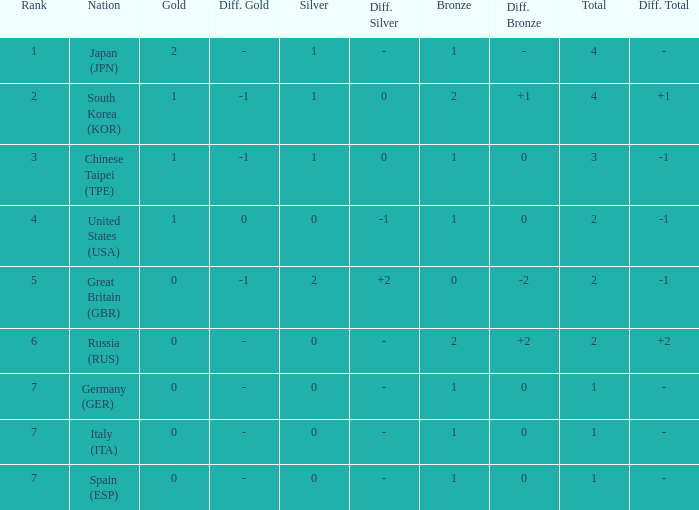What is the smallest number of gold of a country of rank 6, with 2 bronzes? None. Parse the full table. {'header': ['Rank', 'Nation', 'Gold', 'Diff. Gold', 'Silver', 'Diff. Silver', 'Bronze', 'Diff. Bronze', 'Total', 'Diff. Total'], 'rows': [['1', 'Japan (JPN)', '2', '-', '1', '-', '1', '-', '4', '-'], ['2', 'South Korea (KOR)', '1', '-1', '1', '0', '2', '+1', '4', '+1'], ['3', 'Chinese Taipei (TPE)', '1', '-1', '1', '0', '1', '0', '3', '-1'], ['4', 'United States (USA)', '1', '0', '0', '-1', '1', '0', '2', '-1'], ['5', 'Great Britain (GBR)', '0', '-1', '2', '+2', '0', '-2', '2', '-1'], ['6', 'Russia (RUS)', '0', '-', '0', '-', '2', '+2', '2', '+2'], ['7', 'Germany (GER)', '0', '-', '0', '-', '1', '0', '1', '-'], ['7', 'Italy (ITA)', '0', '-', '0', '-', '1', '0', '1', '-'], ['7', 'Spain (ESP)', '0', '-', '0', '-', '1', '0', '1', '-']]} 